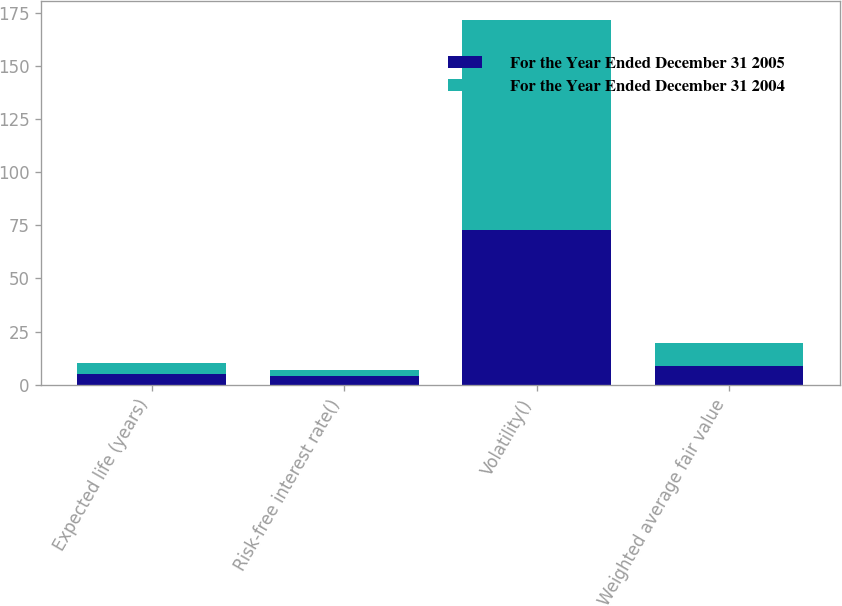<chart> <loc_0><loc_0><loc_500><loc_500><stacked_bar_chart><ecel><fcel>Expected life (years)<fcel>Risk-free interest rate()<fcel>Volatility()<fcel>Weighted average fair value<nl><fcel>For the Year Ended December 31 2005<fcel>5<fcel>4<fcel>72.8<fcel>8.86<nl><fcel>For the Year Ended December 31 2004<fcel>5<fcel>3<fcel>98.9<fcel>10.9<nl></chart> 